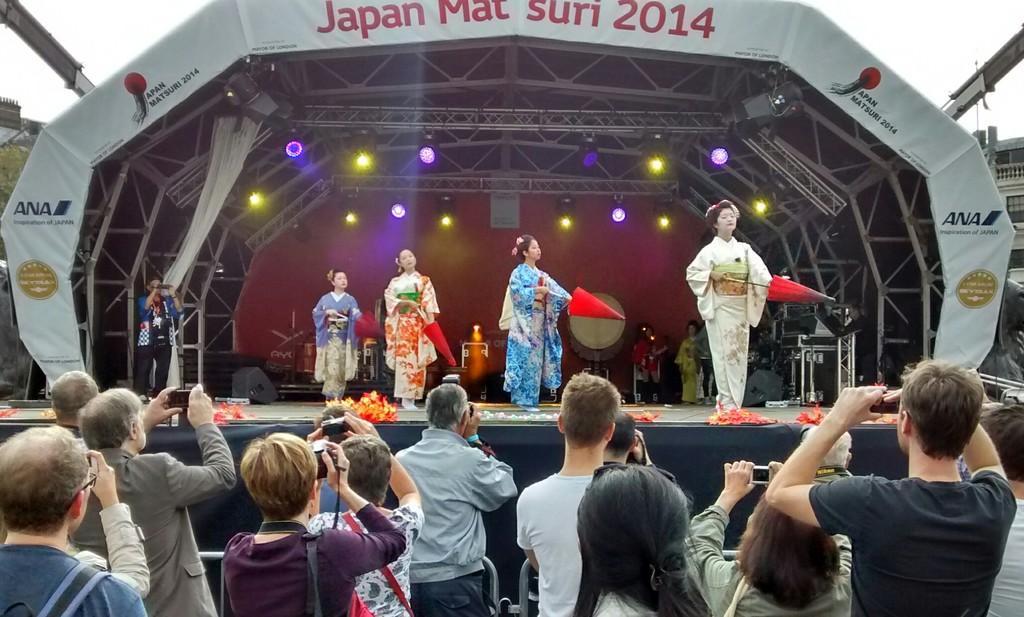In one or two sentences, can you explain what this image depicts? In this image we can see a few people, among them, some people are standing on the ground and holding the objects and some are doing the dance on the stage and holding the objects, there are some focus lights, metal rods, banner with some text and some other objects, in the background, we can see the buildings and the sky. 